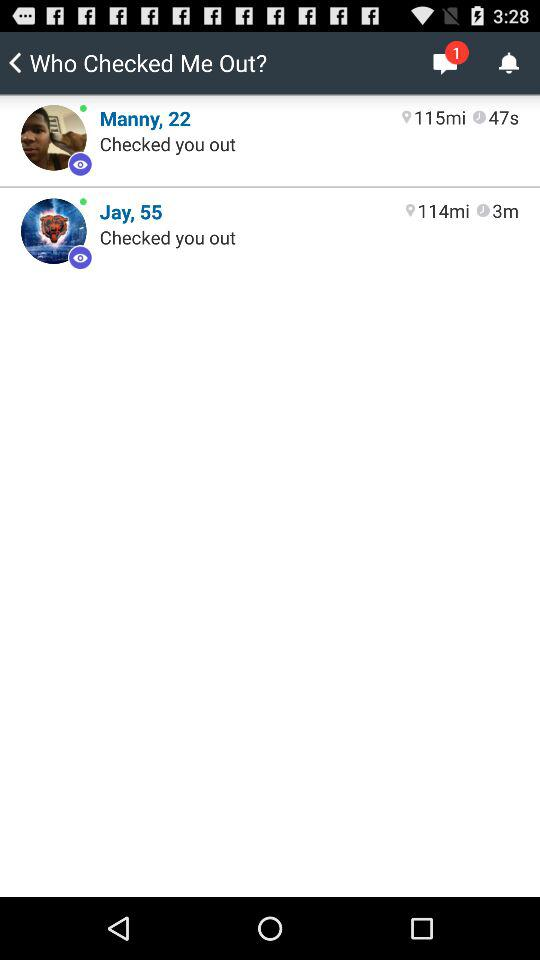Who checked on me 3 minutes ago? You were checked by Jay 3 minutes ago. 